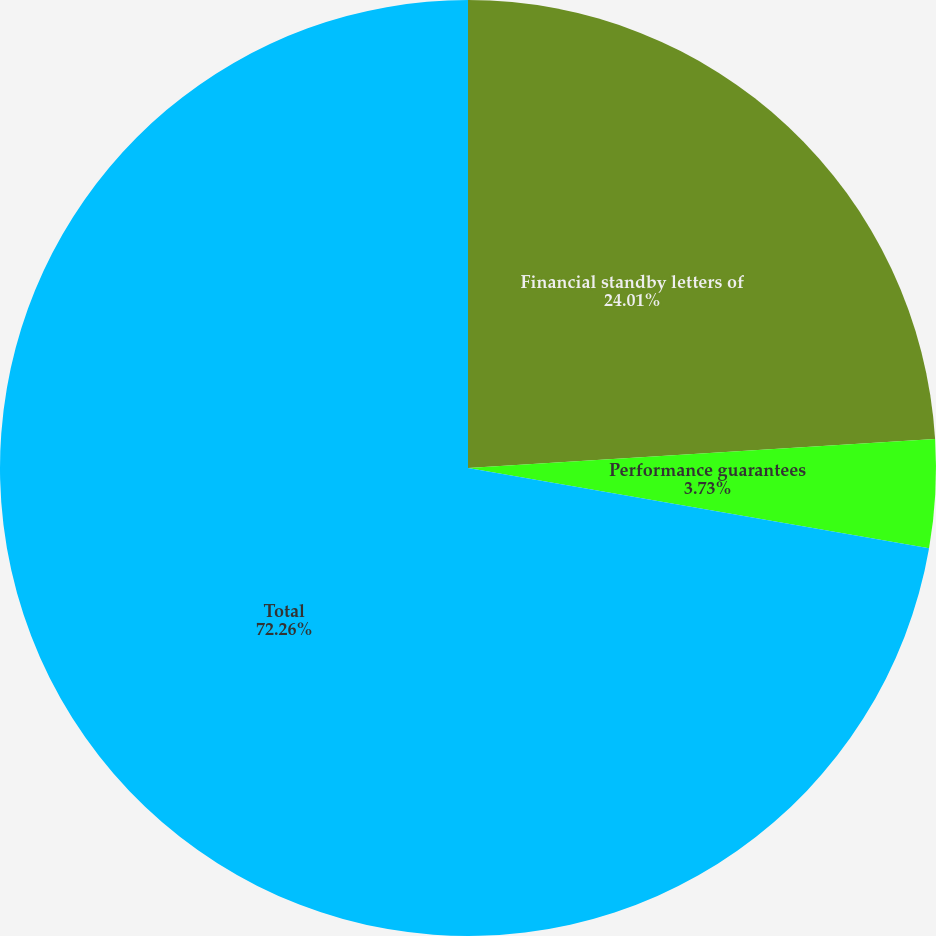<chart> <loc_0><loc_0><loc_500><loc_500><pie_chart><fcel>Financial standby letters of<fcel>Performance guarantees<fcel>Total<nl><fcel>24.01%<fcel>3.73%<fcel>72.25%<nl></chart> 